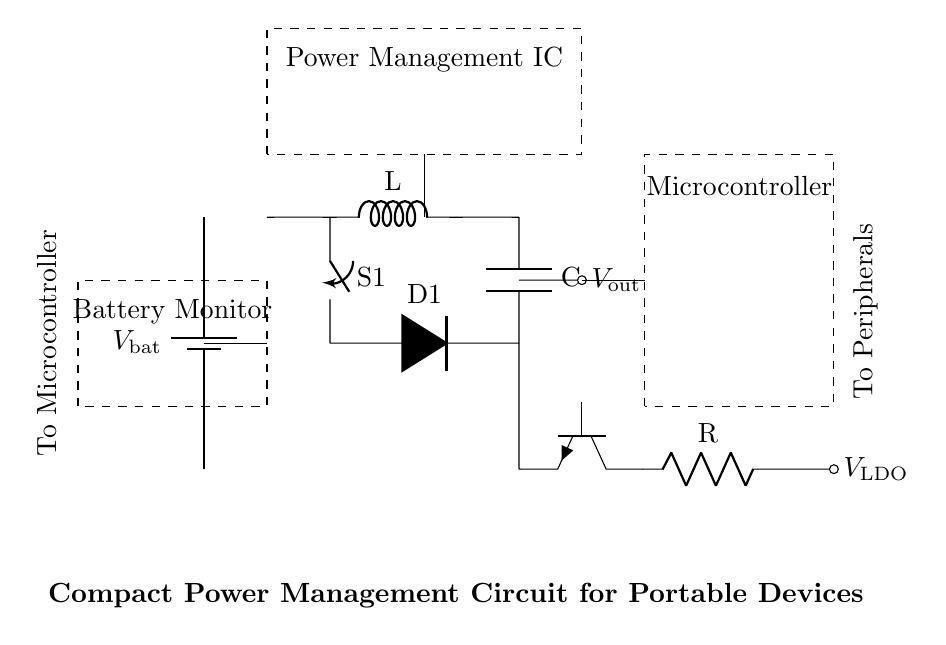What is the battery used in this circuit? The circuit includes a battery component labeled as V_bat, which supplies power to the system.
Answer: V_bat What does the buck-boost converter do? The buck-boost converter adjusts the voltage level from the battery to ensure that V_out remains stable under varying battery conditions.
Answer: Adjusts voltage How many main components are shown in the circuit? The circuit diagram has five main components: Battery, Buck-Boost Converter, Power Management IC, Battery Monitor, and Low Drop-Out Regulator.
Answer: Five What is the primary function of the Power Management IC? The Power Management IC regulates and optimizes power distribution from the battery to various components, increasing overall efficiency.
Answer: Regulates power How does the Low Drop-Out Regulator connect to the main output? The Low Drop-Out Regulator is connected directly to the output of the Buck-Boost Converter and supplies voltage to peripherals.
Answer: Direct connection What component monitors the battery voltage? The battery monitor is the component designated to keep track of the battery voltage and its health status.
Answer: Battery Monitor What do the dashed lines represent in the circuit? The dashed lines indicate the boundaries of components like the Microcontroller, Power Management IC, and Battery Monitor, showing their physical layout without affecting the electrical connections.
Answer: Boundaries 